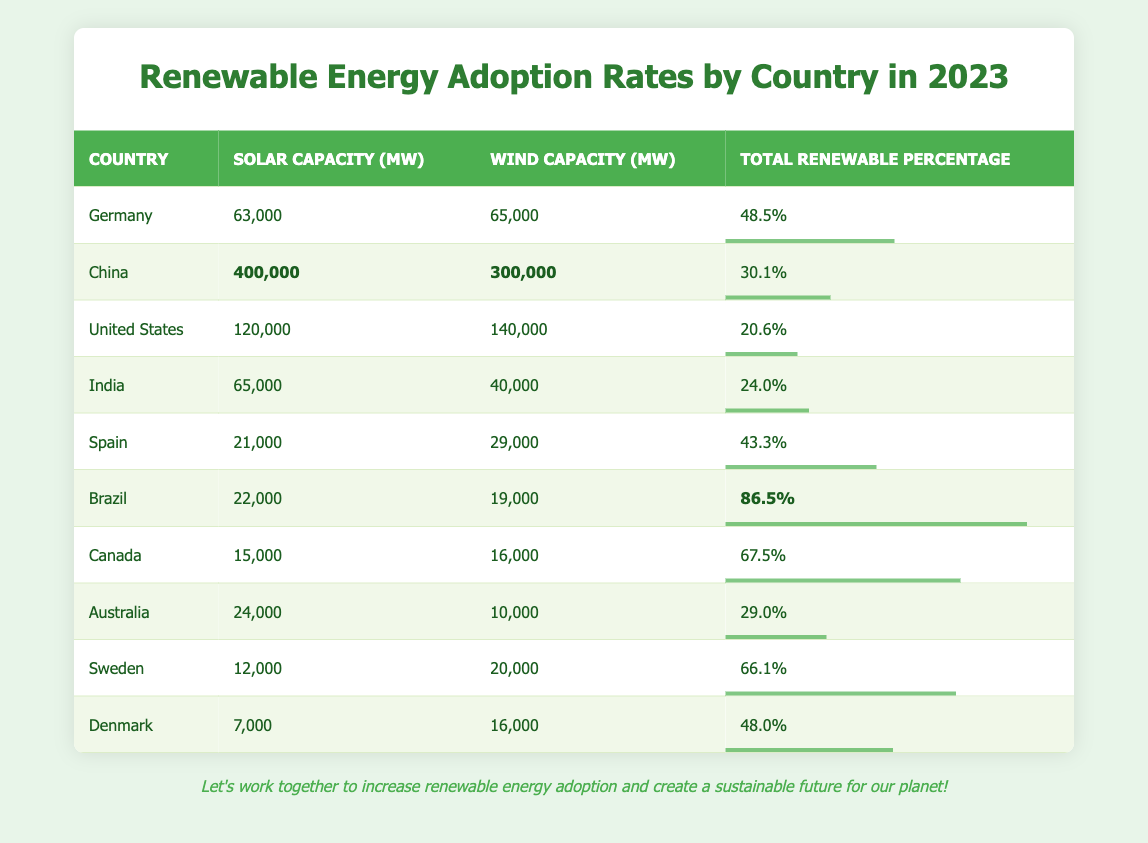What is the total renewable percentage for Germany? The table shows that Germany has a total renewable percentage of 48.5%.
Answer: 48.5% Which country has the highest solar capacity? The data indicates that China has the highest solar capacity with 400,000 MW.
Answer: China How many megawatts of wind capacity does Brazil have? The table states that Brazil has 19,000 MW of wind capacity.
Answer: 19,000 MW What is the total renewable percentage for Canada? Canada has a total renewable percentage of 67.5%, as indicated in the table.
Answer: 67.5% Which two countries have a total renewable percentage greater than 60%? The countries with a renewable percentage greater than 60% are Brazil (86.5%) and Canada (67.5%).
Answer: Brazil and Canada What is the combined solar capacity of Germany and Spain? The solar capacity for Germany is 63,000 MW and for Spain is 21,000 MW. Combining these gives 63,000 + 21,000 = 84,000 MW.
Answer: 84,000 MW Is the total renewable percentage for Australia higher than that for the United States? The table shows Australia has a renewable percentage of 29.0% while the United States has 20.6%, making Australia's percentage higher.
Answer: Yes What is the average renewable percentage of all countries listed? The renewable percentages to average are: 48.5, 30.1, 20.6, 24.0, 43.3, 86.5, 67.5, 29.0, 66.1, 48.0. The total is  48.5 + 30.1 + 20.6 + 24.0 + 43.3 + 86.5 + 67.5 + 29.0 + 66.1 + 48.0 =  424.6. There are 10 countries, so the average is 424.6 / 10 = 42.46.
Answer: 42.46 Which country has the lowest renewable percentage? From the data, the United States has the lowest renewable percentage at 20.6%.
Answer: United States How many megawatts of wind capacity does China have compared to Canada? China has 300,000 MW of wind capacity, while Canada has 16,000 MW. The difference is 300,000 - 16,000 = 284,000 MW, indicating China has significantly more wind capacity.
Answer: 284,000 MW If we were to rank the countries based on total renewable percentage from highest to lowest, what are the first three countries? The top three countries by total renewable percentage are Brazil (86.5%), Canada (67.5%), and Sweden (66.1%).
Answer: Brazil, Canada, Sweden 